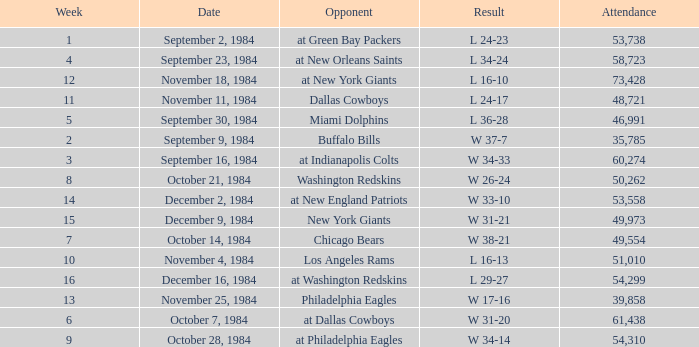What was the result in a week lower than 10 with an opponent of Chicago Bears? W 38-21. 